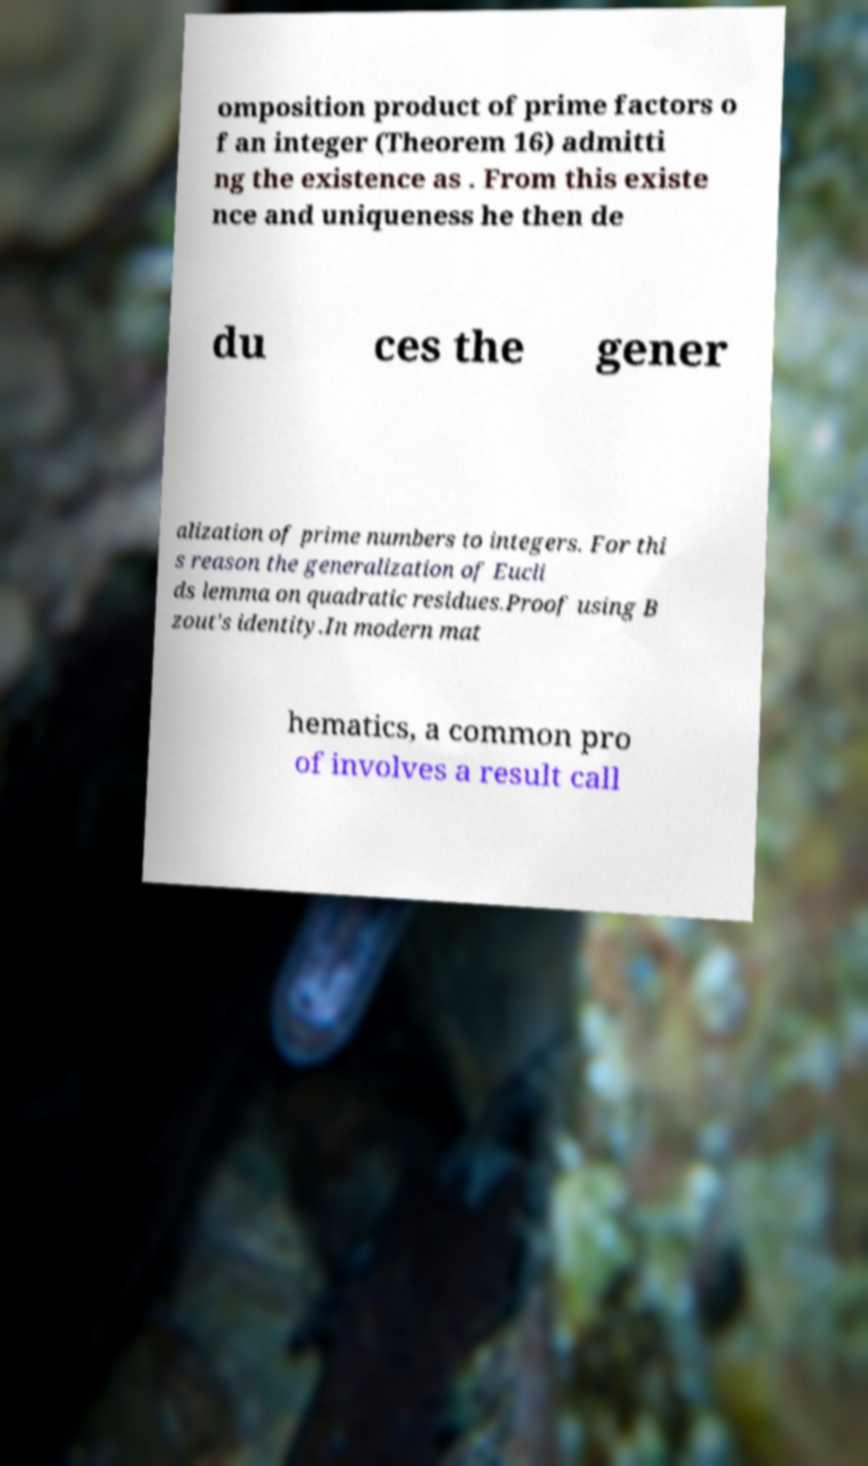I need the written content from this picture converted into text. Can you do that? omposition product of prime factors o f an integer (Theorem 16) admitti ng the existence as . From this existe nce and uniqueness he then de du ces the gener alization of prime numbers to integers. For thi s reason the generalization of Eucli ds lemma on quadratic residues.Proof using B zout's identity.In modern mat hematics, a common pro of involves a result call 